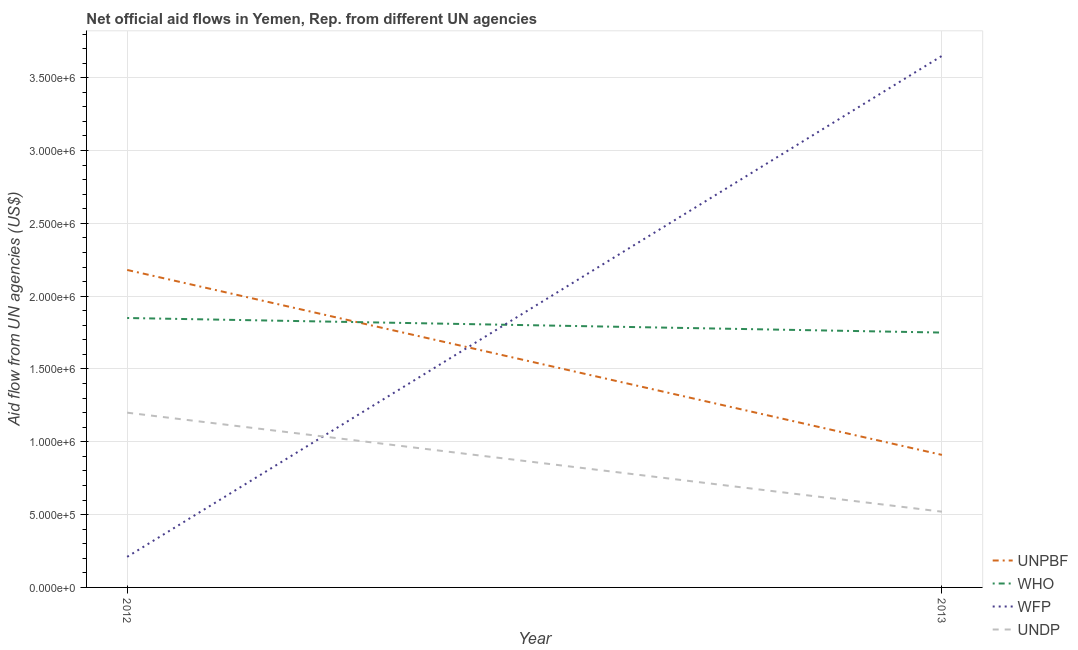How many different coloured lines are there?
Offer a terse response. 4. Is the number of lines equal to the number of legend labels?
Offer a very short reply. Yes. What is the amount of aid given by who in 2013?
Provide a short and direct response. 1.75e+06. Across all years, what is the maximum amount of aid given by who?
Your response must be concise. 1.85e+06. Across all years, what is the minimum amount of aid given by unpbf?
Provide a short and direct response. 9.10e+05. In which year was the amount of aid given by who maximum?
Give a very brief answer. 2012. What is the total amount of aid given by unpbf in the graph?
Your response must be concise. 3.09e+06. What is the difference between the amount of aid given by unpbf in 2012 and that in 2013?
Ensure brevity in your answer.  1.27e+06. What is the difference between the amount of aid given by unpbf in 2012 and the amount of aid given by wfp in 2013?
Ensure brevity in your answer.  -1.47e+06. What is the average amount of aid given by who per year?
Offer a very short reply. 1.80e+06. In the year 2012, what is the difference between the amount of aid given by who and amount of aid given by wfp?
Keep it short and to the point. 1.64e+06. In how many years, is the amount of aid given by who greater than 3600000 US$?
Your answer should be very brief. 0. What is the ratio of the amount of aid given by who in 2012 to that in 2013?
Give a very brief answer. 1.06. In how many years, is the amount of aid given by undp greater than the average amount of aid given by undp taken over all years?
Make the answer very short. 1. Is it the case that in every year, the sum of the amount of aid given by who and amount of aid given by undp is greater than the sum of amount of aid given by unpbf and amount of aid given by wfp?
Your answer should be very brief. No. Is the amount of aid given by undp strictly less than the amount of aid given by unpbf over the years?
Your answer should be compact. Yes. How many lines are there?
Your answer should be compact. 4. How many years are there in the graph?
Your answer should be very brief. 2. Are the values on the major ticks of Y-axis written in scientific E-notation?
Ensure brevity in your answer.  Yes. Does the graph contain grids?
Offer a very short reply. Yes. How many legend labels are there?
Your response must be concise. 4. How are the legend labels stacked?
Provide a short and direct response. Vertical. What is the title of the graph?
Offer a very short reply. Net official aid flows in Yemen, Rep. from different UN agencies. What is the label or title of the X-axis?
Provide a short and direct response. Year. What is the label or title of the Y-axis?
Provide a succinct answer. Aid flow from UN agencies (US$). What is the Aid flow from UN agencies (US$) of UNPBF in 2012?
Offer a terse response. 2.18e+06. What is the Aid flow from UN agencies (US$) in WHO in 2012?
Keep it short and to the point. 1.85e+06. What is the Aid flow from UN agencies (US$) of UNDP in 2012?
Your answer should be compact. 1.20e+06. What is the Aid flow from UN agencies (US$) of UNPBF in 2013?
Offer a terse response. 9.10e+05. What is the Aid flow from UN agencies (US$) of WHO in 2013?
Ensure brevity in your answer.  1.75e+06. What is the Aid flow from UN agencies (US$) of WFP in 2013?
Provide a short and direct response. 3.65e+06. What is the Aid flow from UN agencies (US$) of UNDP in 2013?
Give a very brief answer. 5.20e+05. Across all years, what is the maximum Aid flow from UN agencies (US$) in UNPBF?
Your response must be concise. 2.18e+06. Across all years, what is the maximum Aid flow from UN agencies (US$) in WHO?
Offer a very short reply. 1.85e+06. Across all years, what is the maximum Aid flow from UN agencies (US$) of WFP?
Offer a terse response. 3.65e+06. Across all years, what is the maximum Aid flow from UN agencies (US$) in UNDP?
Your answer should be compact. 1.20e+06. Across all years, what is the minimum Aid flow from UN agencies (US$) in UNPBF?
Give a very brief answer. 9.10e+05. Across all years, what is the minimum Aid flow from UN agencies (US$) in WHO?
Offer a terse response. 1.75e+06. Across all years, what is the minimum Aid flow from UN agencies (US$) of WFP?
Keep it short and to the point. 2.10e+05. Across all years, what is the minimum Aid flow from UN agencies (US$) in UNDP?
Offer a very short reply. 5.20e+05. What is the total Aid flow from UN agencies (US$) in UNPBF in the graph?
Your answer should be very brief. 3.09e+06. What is the total Aid flow from UN agencies (US$) of WHO in the graph?
Ensure brevity in your answer.  3.60e+06. What is the total Aid flow from UN agencies (US$) in WFP in the graph?
Your answer should be compact. 3.86e+06. What is the total Aid flow from UN agencies (US$) of UNDP in the graph?
Give a very brief answer. 1.72e+06. What is the difference between the Aid flow from UN agencies (US$) in UNPBF in 2012 and that in 2013?
Provide a succinct answer. 1.27e+06. What is the difference between the Aid flow from UN agencies (US$) of WFP in 2012 and that in 2013?
Provide a succinct answer. -3.44e+06. What is the difference between the Aid flow from UN agencies (US$) of UNDP in 2012 and that in 2013?
Offer a terse response. 6.80e+05. What is the difference between the Aid flow from UN agencies (US$) of UNPBF in 2012 and the Aid flow from UN agencies (US$) of WFP in 2013?
Your answer should be very brief. -1.47e+06. What is the difference between the Aid flow from UN agencies (US$) in UNPBF in 2012 and the Aid flow from UN agencies (US$) in UNDP in 2013?
Offer a very short reply. 1.66e+06. What is the difference between the Aid flow from UN agencies (US$) in WHO in 2012 and the Aid flow from UN agencies (US$) in WFP in 2013?
Provide a short and direct response. -1.80e+06. What is the difference between the Aid flow from UN agencies (US$) of WHO in 2012 and the Aid flow from UN agencies (US$) of UNDP in 2013?
Provide a succinct answer. 1.33e+06. What is the difference between the Aid flow from UN agencies (US$) of WFP in 2012 and the Aid flow from UN agencies (US$) of UNDP in 2013?
Your answer should be compact. -3.10e+05. What is the average Aid flow from UN agencies (US$) in UNPBF per year?
Provide a succinct answer. 1.54e+06. What is the average Aid flow from UN agencies (US$) of WHO per year?
Ensure brevity in your answer.  1.80e+06. What is the average Aid flow from UN agencies (US$) in WFP per year?
Your answer should be very brief. 1.93e+06. What is the average Aid flow from UN agencies (US$) in UNDP per year?
Make the answer very short. 8.60e+05. In the year 2012, what is the difference between the Aid flow from UN agencies (US$) in UNPBF and Aid flow from UN agencies (US$) in WFP?
Provide a short and direct response. 1.97e+06. In the year 2012, what is the difference between the Aid flow from UN agencies (US$) of UNPBF and Aid flow from UN agencies (US$) of UNDP?
Your answer should be very brief. 9.80e+05. In the year 2012, what is the difference between the Aid flow from UN agencies (US$) in WHO and Aid flow from UN agencies (US$) in WFP?
Your answer should be compact. 1.64e+06. In the year 2012, what is the difference between the Aid flow from UN agencies (US$) of WHO and Aid flow from UN agencies (US$) of UNDP?
Give a very brief answer. 6.50e+05. In the year 2012, what is the difference between the Aid flow from UN agencies (US$) in WFP and Aid flow from UN agencies (US$) in UNDP?
Provide a short and direct response. -9.90e+05. In the year 2013, what is the difference between the Aid flow from UN agencies (US$) of UNPBF and Aid flow from UN agencies (US$) of WHO?
Your response must be concise. -8.40e+05. In the year 2013, what is the difference between the Aid flow from UN agencies (US$) in UNPBF and Aid flow from UN agencies (US$) in WFP?
Offer a very short reply. -2.74e+06. In the year 2013, what is the difference between the Aid flow from UN agencies (US$) of WHO and Aid flow from UN agencies (US$) of WFP?
Keep it short and to the point. -1.90e+06. In the year 2013, what is the difference between the Aid flow from UN agencies (US$) in WHO and Aid flow from UN agencies (US$) in UNDP?
Offer a terse response. 1.23e+06. In the year 2013, what is the difference between the Aid flow from UN agencies (US$) of WFP and Aid flow from UN agencies (US$) of UNDP?
Keep it short and to the point. 3.13e+06. What is the ratio of the Aid flow from UN agencies (US$) of UNPBF in 2012 to that in 2013?
Offer a very short reply. 2.4. What is the ratio of the Aid flow from UN agencies (US$) of WHO in 2012 to that in 2013?
Your answer should be very brief. 1.06. What is the ratio of the Aid flow from UN agencies (US$) of WFP in 2012 to that in 2013?
Your response must be concise. 0.06. What is the ratio of the Aid flow from UN agencies (US$) in UNDP in 2012 to that in 2013?
Offer a terse response. 2.31. What is the difference between the highest and the second highest Aid flow from UN agencies (US$) of UNPBF?
Offer a very short reply. 1.27e+06. What is the difference between the highest and the second highest Aid flow from UN agencies (US$) in WFP?
Your response must be concise. 3.44e+06. What is the difference between the highest and the second highest Aid flow from UN agencies (US$) in UNDP?
Keep it short and to the point. 6.80e+05. What is the difference between the highest and the lowest Aid flow from UN agencies (US$) of UNPBF?
Keep it short and to the point. 1.27e+06. What is the difference between the highest and the lowest Aid flow from UN agencies (US$) in WFP?
Provide a succinct answer. 3.44e+06. What is the difference between the highest and the lowest Aid flow from UN agencies (US$) in UNDP?
Provide a succinct answer. 6.80e+05. 